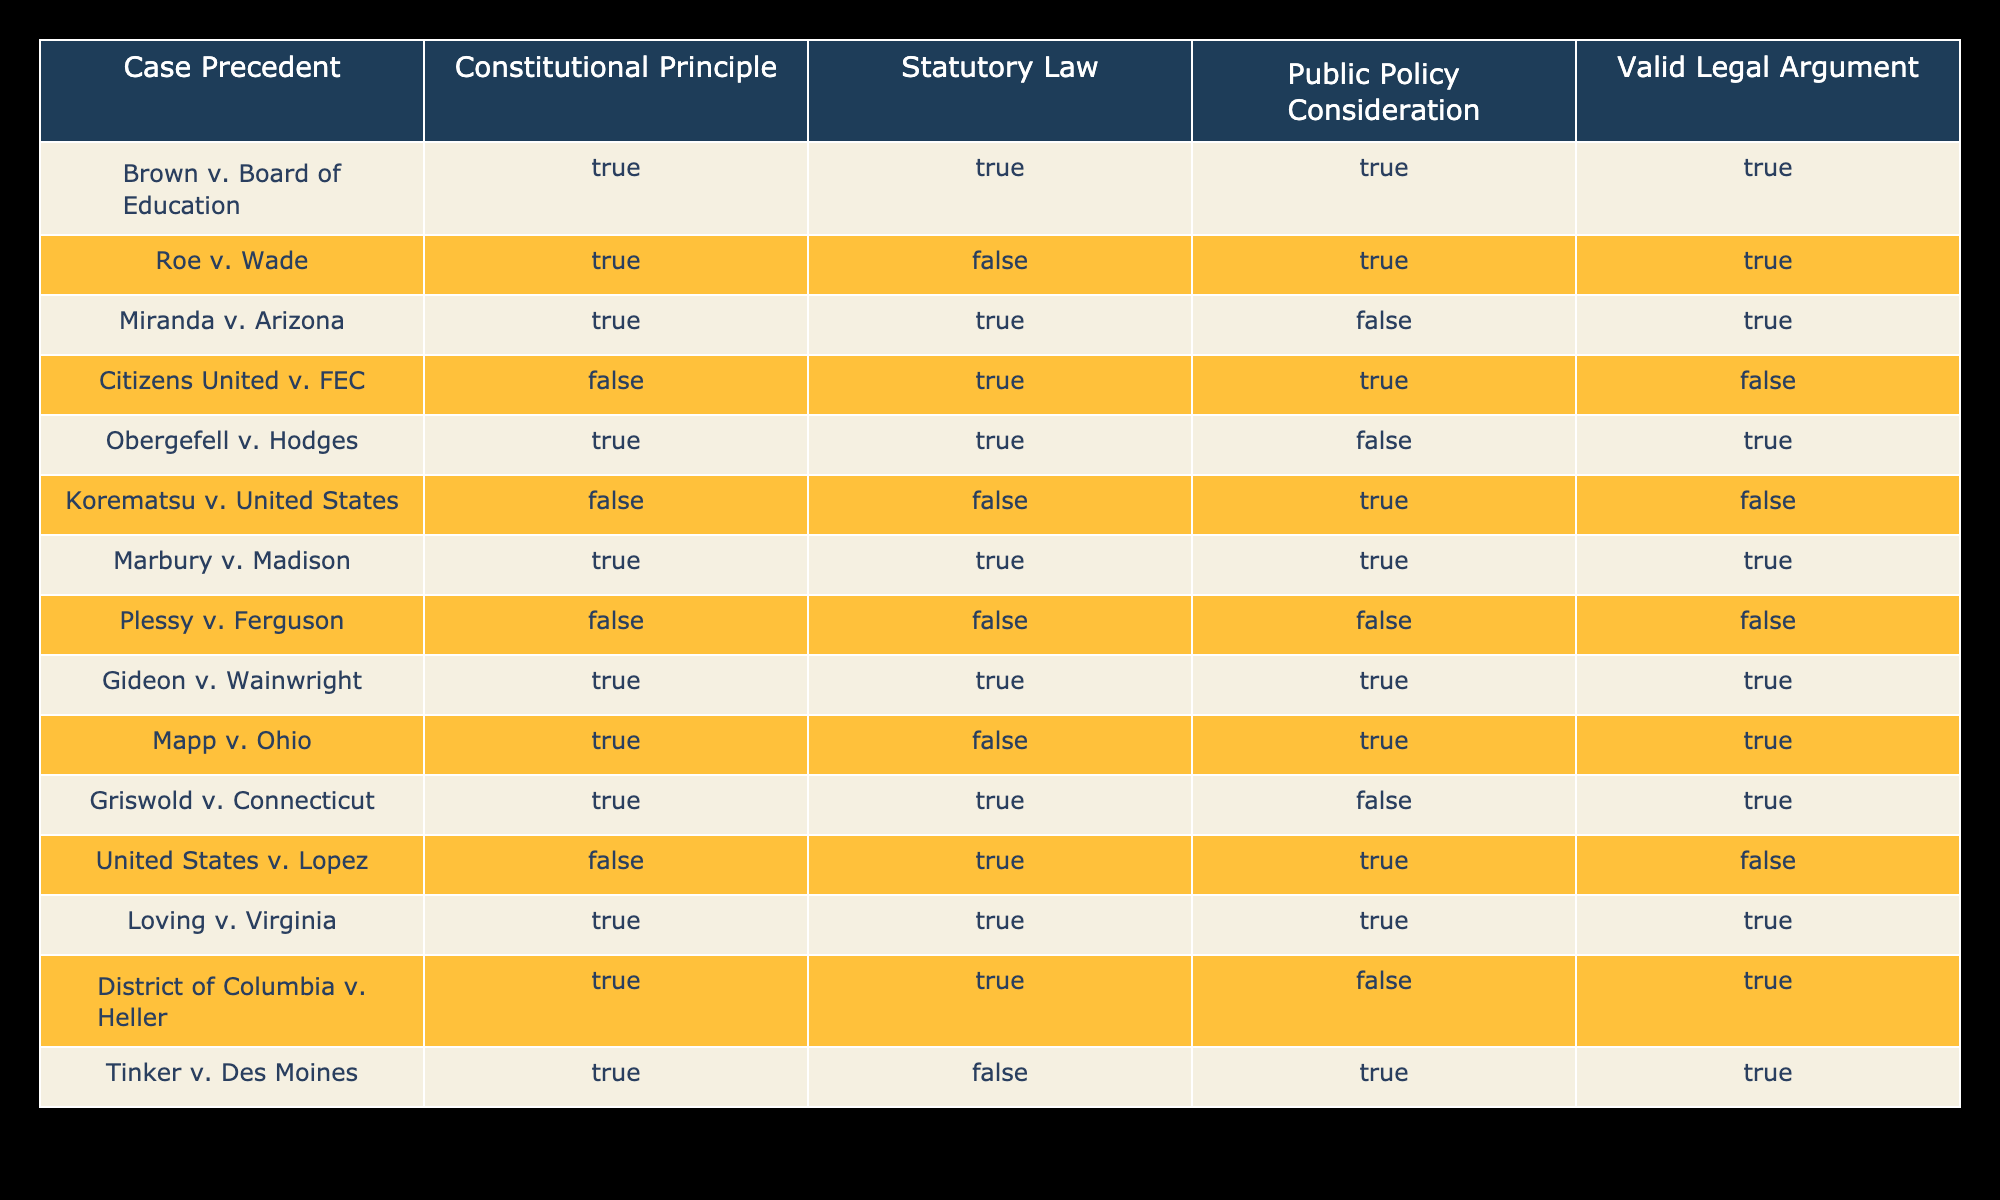What is the valid legal argument in Brown v. Board of Education? According to the table, Brown v. Board of Education has a "Valid Legal Argument" value of TRUE, which indicates it is considered a valid legal argument.
Answer: TRUE Which cases have a valid legal argument but have a FALSE value for Constitutional Principle? The table shows that Roe v. Wade has a TRUE value for "Valid Legal Argument" and a FALSE value for "Constitutional Principle." Additionally, Mapp v. Ohio also has a valid legal argument but lacks constitutional backing, giving us these two examples.
Answer: Roe v. Wade, Mapp v. Ohio Count how many cases have a valid legal argument based on Public Policy Consideration. From the table, we see that Brown v. Board of Education, Roe v. Wade, Miranda v. Arizona, Obergefell v. Hodges, Mapp v. Ohio, Griswold v. Connecticut, Tinker v. Des Moines each have TRUE in "Public Policy Consideration" and are valid legal arguments. This gives us a total of 6 cases.
Answer: 6 Is there a case with a FALSE value for both Statutory Law and Valid Legal Argument? Looking at the table, Korematsu v. United States has FALSE values for both "Statutory Law" and "Valid Legal Argument," thus confirming that such a case exists.
Answer: TRUE How many cases have Valid Legal Argument as TRUE, Constitutional Principle as TRUE, and Statutory Law as TRUE? By examining the table carefully, we find that the following cases meet these criteria: Brown v. Board of Education, Marbury v. Madison, Gideon v. Wainwright. Thus, counting these gives us a total of 3 cases where all three conditions are satisfied.
Answer: 3 Are there any cases that lack validity in legal arguments yet include a TRUE value for Public Policy Consideration? The table indicates that Citizens United v. FEC and United States v. Lopez both have FALSE for "Valid Legal Argument" but TRUE for "Public Policy Consideration," confirming that such cases exist.
Answer: YES Identify the case with the only FALSE value in both Statutory Law and Public Policy Consideration while having no valid legal argument. By reviewing the table, Plessy v. Ferguson stands out as the case that has FALSE for both "Statutory Law" and "Public Policy Consideration" and also has FALSE for "Valid Legal Argument."
Answer: Plessy v. Ferguson Which case has a valid legal argument and TRUE values for both Constitutional Principle and Public Policy Consideration, but FALSE for Statutory Law? Upon analysis, Miranda v. Arizona showcases a valid legal argument along with TRUE for "Constitutional Principle" and "Public Policy Consideration," while maintaining a FALSE for "Statutory Law."
Answer: Miranda v. Arizona 